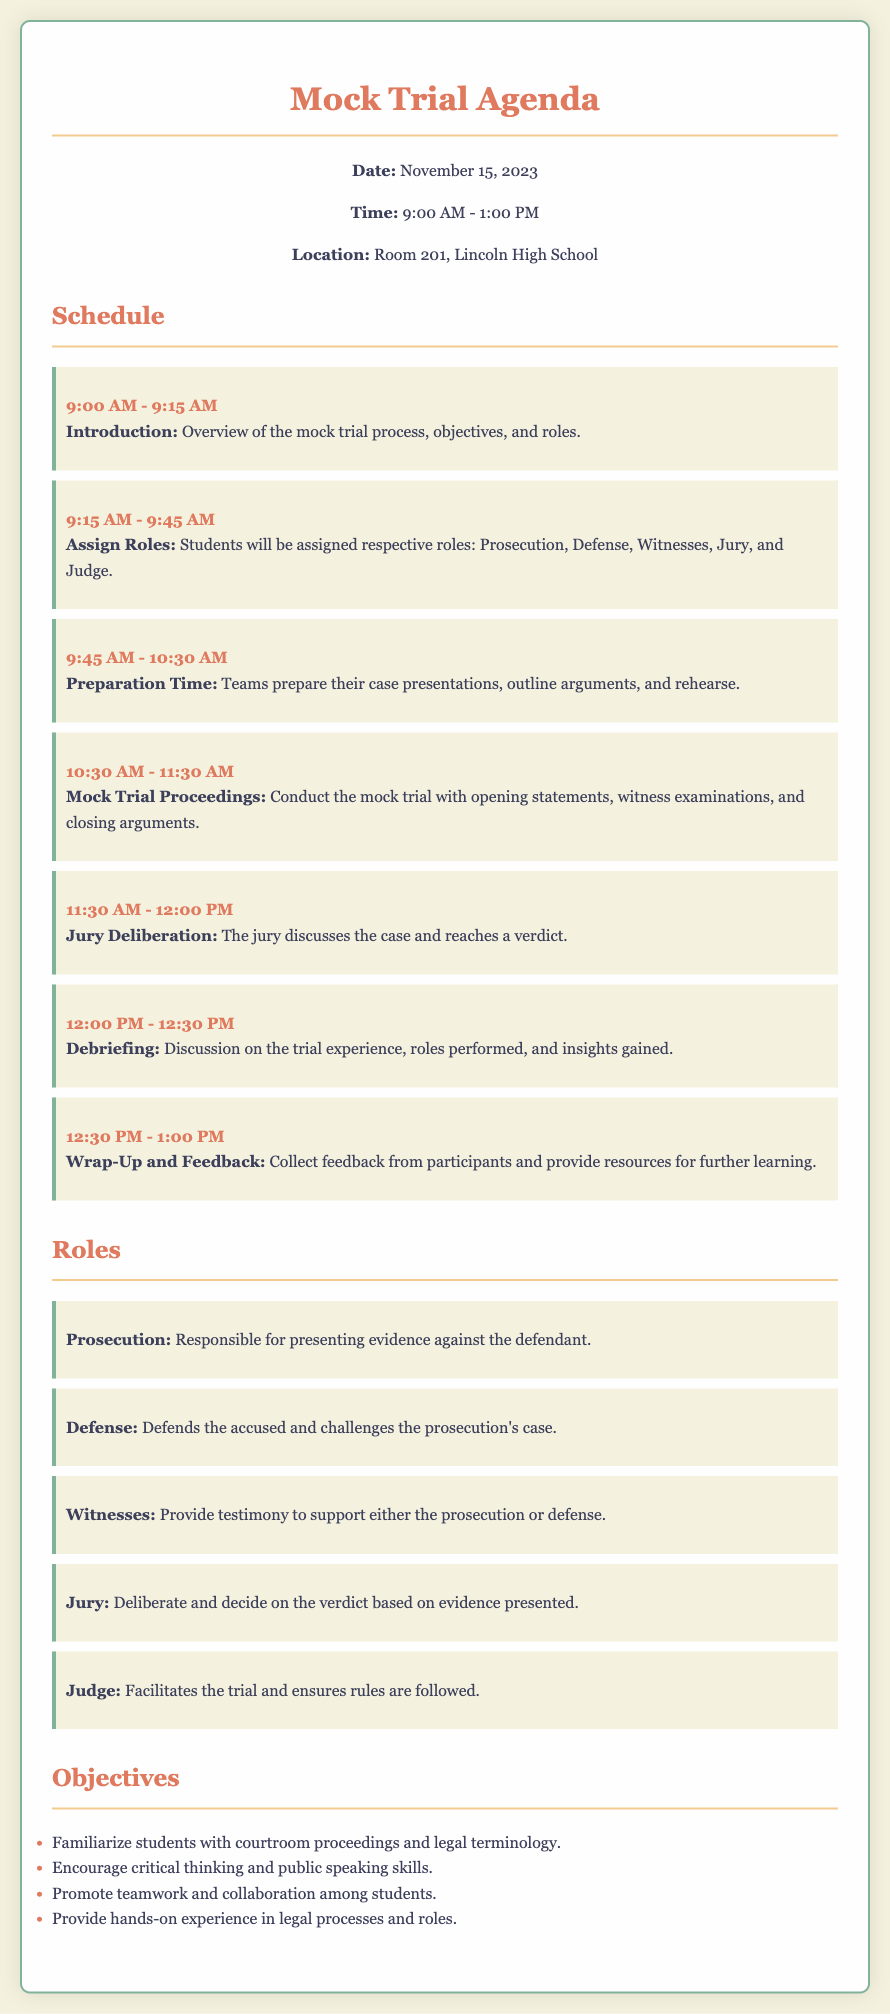What is the date of the mock trial? The date is explicitly mentioned in the document under the header "Date."
Answer: November 15, 2023 What time does the mock trial start? The starting time is specified in the document under the header "Time."
Answer: 9:00 AM Where is the mock trial being held? The location is noted in the document under the header "Location."
Answer: Room 201, Lincoln High School What role is responsible for presenting evidence against the defendant? The document defines the roles, stating the prosecution's duties.
Answer: Prosecution What is the objective related to teamwork? The document lists objectives, one of which pertains to teamwork.
Answer: Promote teamwork and collaboration among students How long is the Jury Deliberation scheduled to last? The duration of the Jury Deliberation is noted in the schedule section of the document.
Answer: 30 minutes What follows the mock trial proceedings? The sequence of events is laid out, with Jury Deliberation being followed by another activity.
Answer: Debriefing How many roles are assigned to students? The document outlines the specific roles, and each is counted to determine the total.
Answer: Five roles What is the purpose of the Wrap-Up and Feedback session? The document details the focus of this session, indicating its intent.
Answer: Collect feedback from participants and provide resources for further learning 